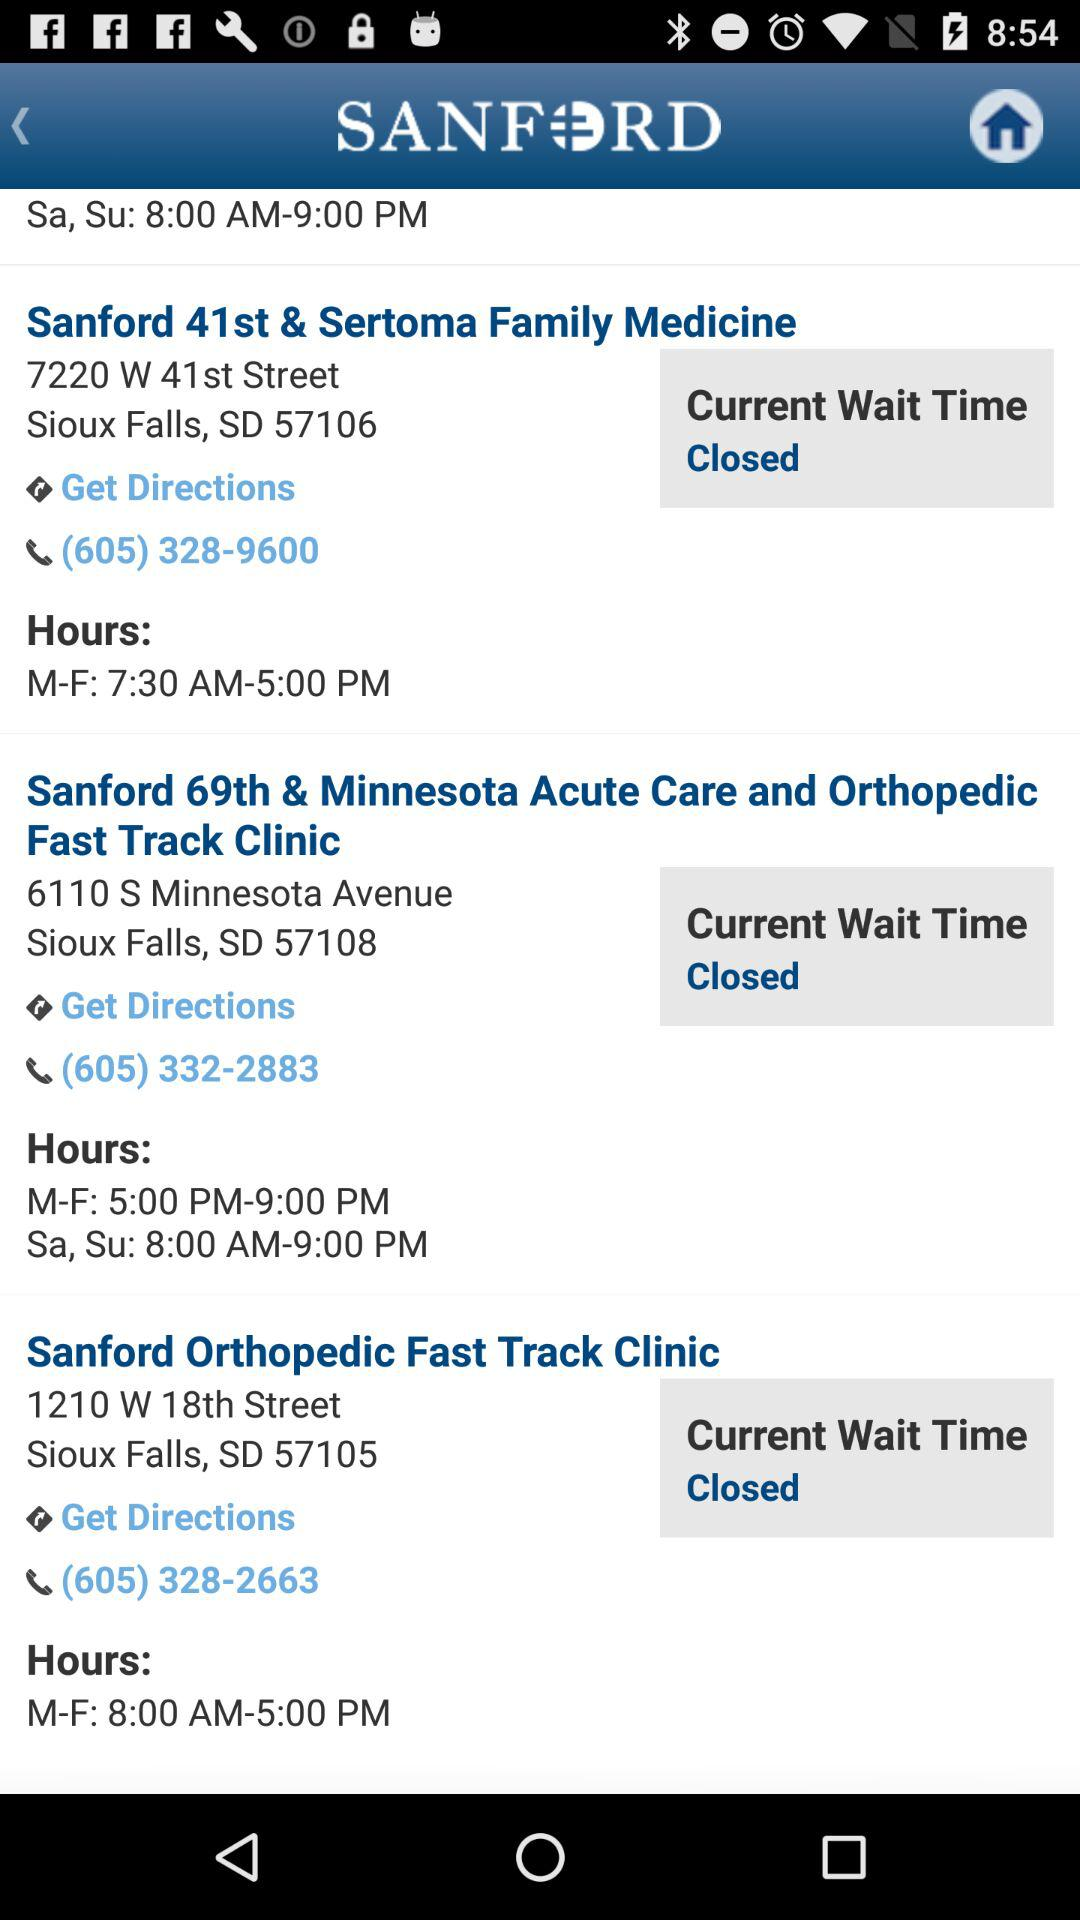What is the contact number of "Sanford 69th & Minnesota Acute Care and Orthopedic Fast Track Clinic"? The contact number is (605) 332-2883. 